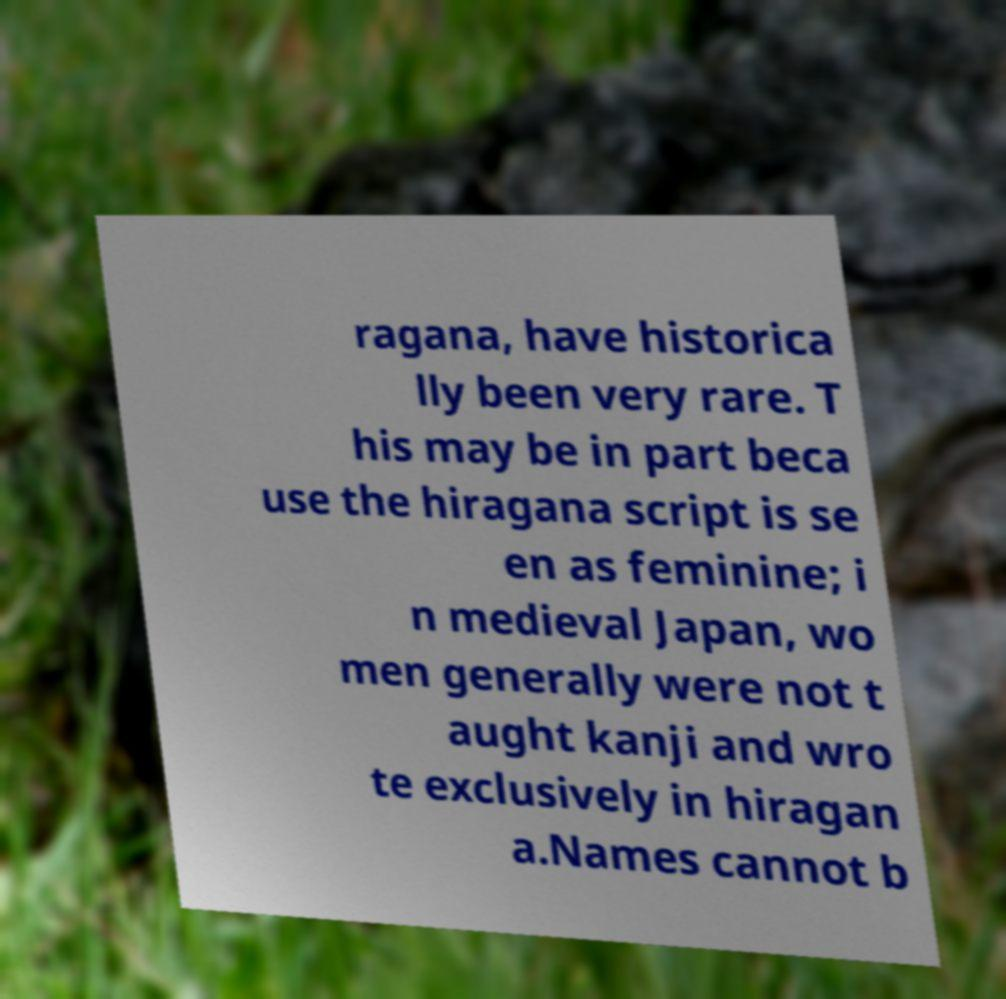Can you read and provide the text displayed in the image?This photo seems to have some interesting text. Can you extract and type it out for me? ragana, have historica lly been very rare. T his may be in part beca use the hiragana script is se en as feminine; i n medieval Japan, wo men generally were not t aught kanji and wro te exclusively in hiragan a.Names cannot b 